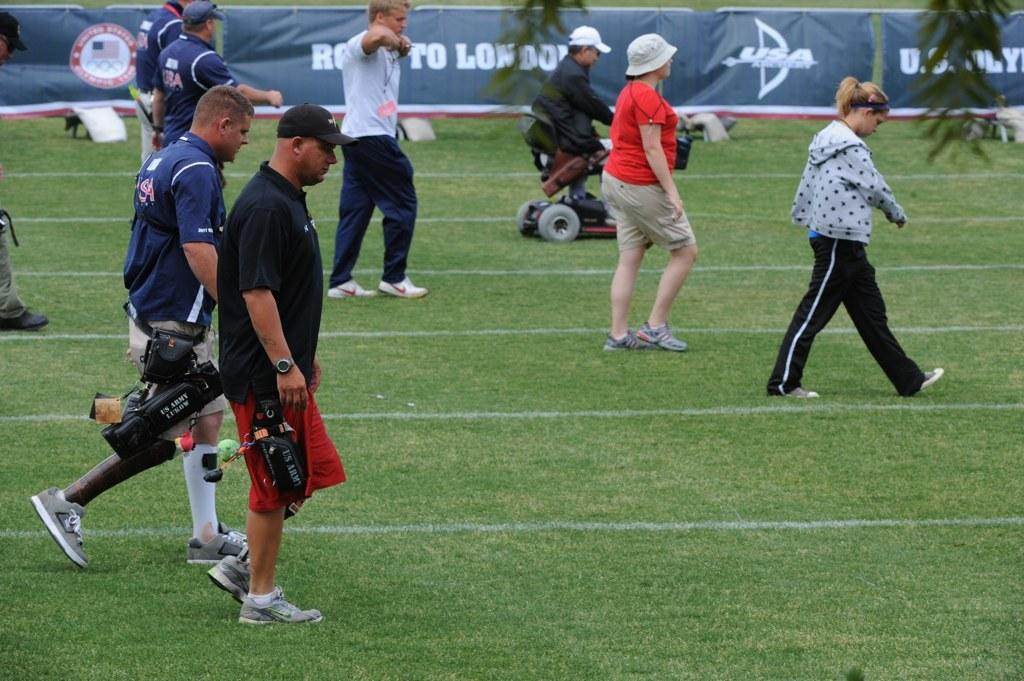<image>
Share a concise interpretation of the image provided. People walk across a sports field in front of a blue banner that has the word London on it. 